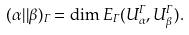<formula> <loc_0><loc_0><loc_500><loc_500>( \alpha | | \beta ) _ { \Gamma } = \dim E _ { \Gamma } ( U _ { \alpha } ^ { \Gamma } , U _ { \beta } ^ { \Gamma } ) .</formula> 